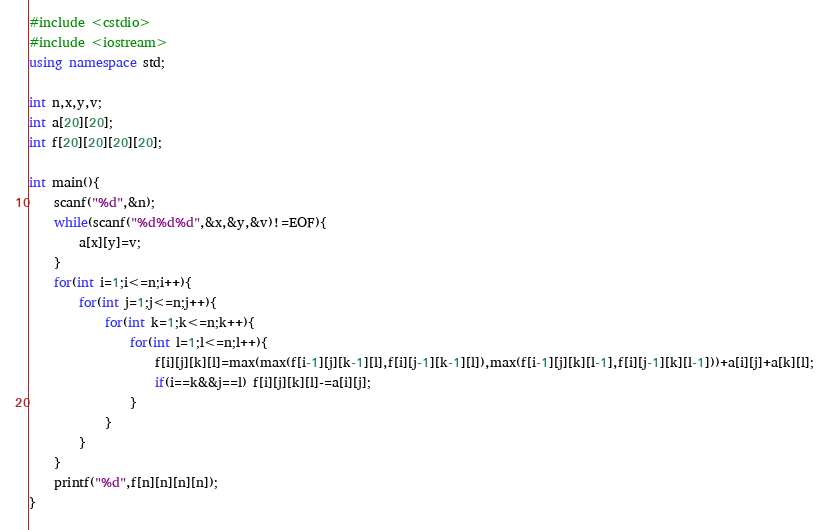<code> <loc_0><loc_0><loc_500><loc_500><_C++_>#include <cstdio>
#include <iostream>
using namespace std;

int n,x,y,v;
int a[20][20];
int f[20][20][20][20];

int main(){
    scanf("%d",&n);
    while(scanf("%d%d%d",&x,&y,&v)!=EOF){
        a[x][y]=v;
    }
    for(int i=1;i<=n;i++){
        for(int j=1;j<=n;j++){
            for(int k=1;k<=n;k++){
                for(int l=1;l<=n;l++){
                    f[i][j][k][l]=max(max(f[i-1][j][k-1][l],f[i][j-1][k-1][l]),max(f[i-1][j][k][l-1],f[i][j-1][k][l-1]))+a[i][j]+a[k][l];
                    if(i==k&&j==l) f[i][j][k][l]-=a[i][j];
                }
            }
        }
    }
    printf("%d",f[n][n][n][n]);
}
</code> 